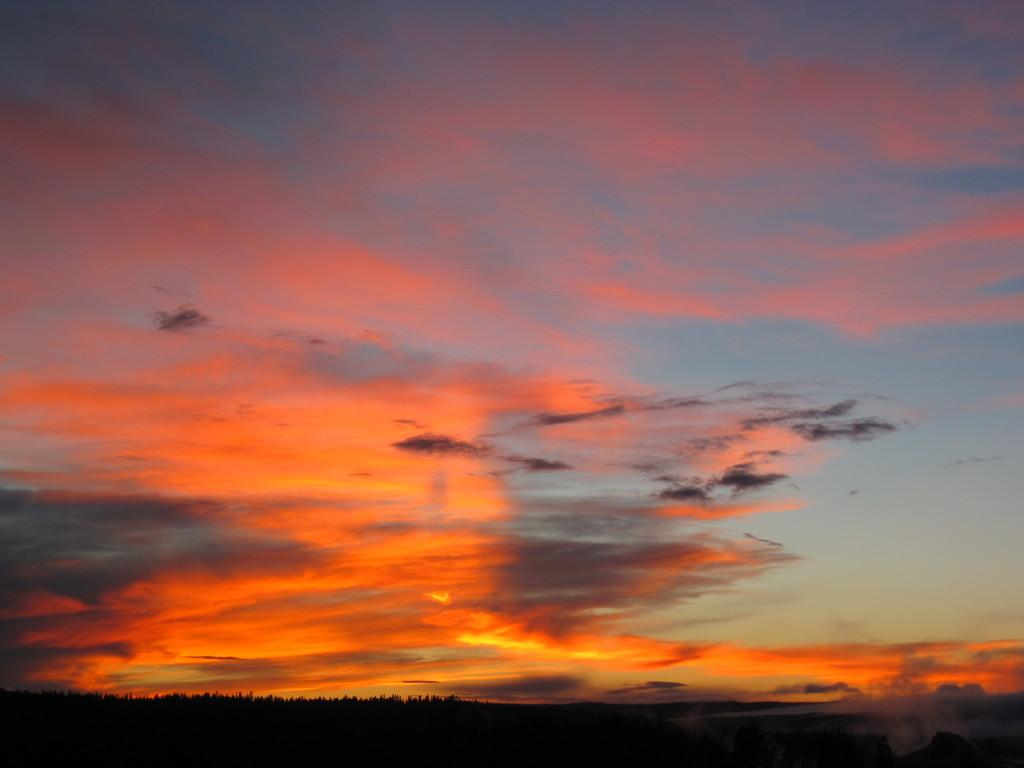What part of the natural environment can be seen in the image? The sky is visible in the image. Can you describe the color or condition of the sky? The provided facts do not mention the color or condition of the sky. What might be visible in the sky, such as clouds or the sun? The provided facts do not mention any specific features of the sky. How many dolls are sitting on the dogs in the image? There are no dolls or dogs present in the image; only the sky is visible. 